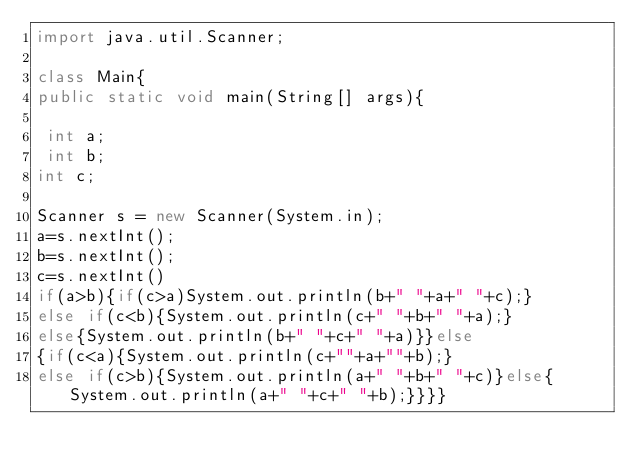Convert code to text. <code><loc_0><loc_0><loc_500><loc_500><_Java_>import java.util.Scanner;

class Main{
public static void main(String[] args){

 int a;
 int b;
int c;

Scanner s = new Scanner(System.in);
a=s.nextInt();
b=s.nextInt();
c=s.nextInt()
if(a>b){if(c>a)System.out.println(b+" "+a+" "+c);}
else if(c<b){System.out.println(c+" "+b+" "+a);}
else{System.out.println(b+" "+c+" "+a)}}else
{if(c<a){System.out.println(c+""+a+""+b);}
else if(c>b){System.out.println(a+" "+b+" "+c)}else{System.out.println(a+" "+c+" "+b);}}}}
</code> 